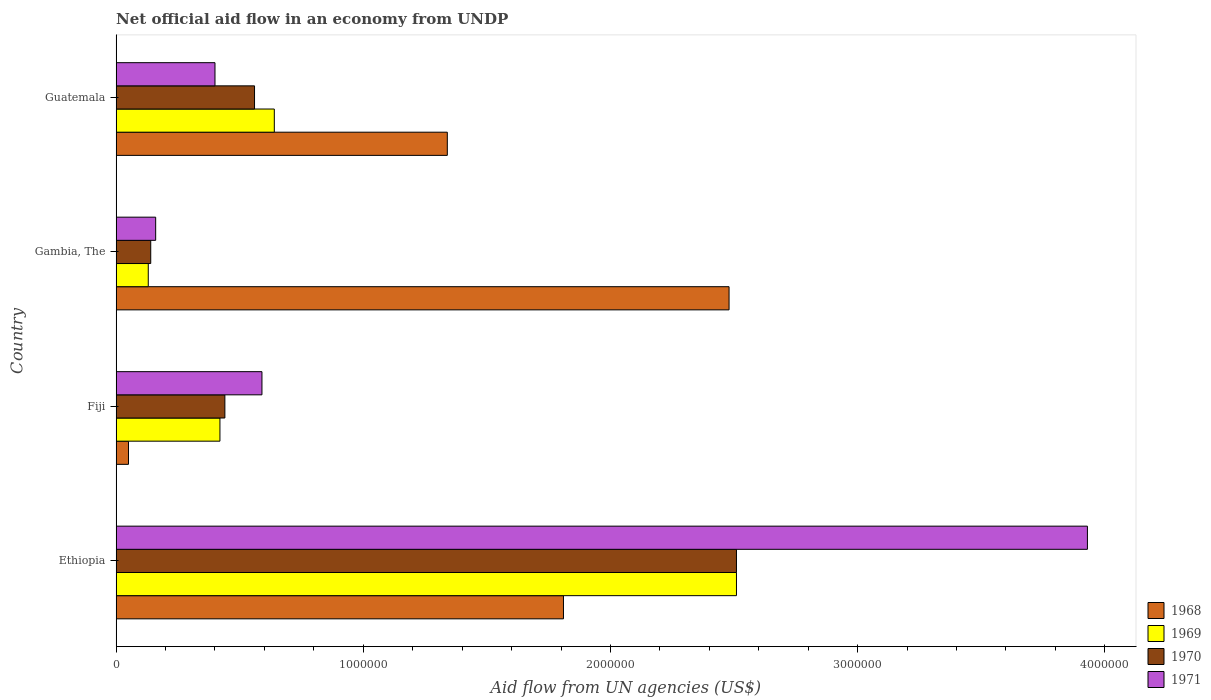Are the number of bars per tick equal to the number of legend labels?
Your answer should be very brief. Yes. Are the number of bars on each tick of the Y-axis equal?
Your answer should be very brief. Yes. What is the label of the 2nd group of bars from the top?
Provide a succinct answer. Gambia, The. What is the net official aid flow in 1968 in Gambia, The?
Keep it short and to the point. 2.48e+06. Across all countries, what is the maximum net official aid flow in 1970?
Make the answer very short. 2.51e+06. Across all countries, what is the minimum net official aid flow in 1968?
Your response must be concise. 5.00e+04. In which country was the net official aid flow in 1968 maximum?
Make the answer very short. Gambia, The. In which country was the net official aid flow in 1968 minimum?
Give a very brief answer. Fiji. What is the total net official aid flow in 1968 in the graph?
Ensure brevity in your answer.  5.68e+06. What is the difference between the net official aid flow in 1968 in Ethiopia and that in Gambia, The?
Your answer should be compact. -6.70e+05. What is the difference between the net official aid flow in 1971 in Guatemala and the net official aid flow in 1968 in Gambia, The?
Your response must be concise. -2.08e+06. What is the average net official aid flow in 1971 per country?
Your response must be concise. 1.27e+06. What is the difference between the net official aid flow in 1968 and net official aid flow in 1971 in Ethiopia?
Ensure brevity in your answer.  -2.12e+06. What is the ratio of the net official aid flow in 1971 in Fiji to that in Guatemala?
Your answer should be very brief. 1.48. Is the net official aid flow in 1971 in Fiji less than that in Guatemala?
Make the answer very short. No. Is the difference between the net official aid flow in 1968 in Fiji and Guatemala greater than the difference between the net official aid flow in 1971 in Fiji and Guatemala?
Provide a succinct answer. No. What is the difference between the highest and the second highest net official aid flow in 1971?
Offer a terse response. 3.34e+06. What is the difference between the highest and the lowest net official aid flow in 1970?
Ensure brevity in your answer.  2.37e+06. Is it the case that in every country, the sum of the net official aid flow in 1971 and net official aid flow in 1969 is greater than the sum of net official aid flow in 1970 and net official aid flow in 1968?
Offer a very short reply. No. What does the 1st bar from the top in Gambia, The represents?
Keep it short and to the point. 1971. What does the 1st bar from the bottom in Ethiopia represents?
Your answer should be compact. 1968. Is it the case that in every country, the sum of the net official aid flow in 1970 and net official aid flow in 1971 is greater than the net official aid flow in 1968?
Ensure brevity in your answer.  No. How many bars are there?
Keep it short and to the point. 16. Are all the bars in the graph horizontal?
Provide a succinct answer. Yes. How many countries are there in the graph?
Ensure brevity in your answer.  4. What is the difference between two consecutive major ticks on the X-axis?
Your answer should be very brief. 1.00e+06. Where does the legend appear in the graph?
Provide a short and direct response. Bottom right. How are the legend labels stacked?
Keep it short and to the point. Vertical. What is the title of the graph?
Provide a succinct answer. Net official aid flow in an economy from UNDP. What is the label or title of the X-axis?
Provide a short and direct response. Aid flow from UN agencies (US$). What is the label or title of the Y-axis?
Ensure brevity in your answer.  Country. What is the Aid flow from UN agencies (US$) in 1968 in Ethiopia?
Your response must be concise. 1.81e+06. What is the Aid flow from UN agencies (US$) in 1969 in Ethiopia?
Keep it short and to the point. 2.51e+06. What is the Aid flow from UN agencies (US$) of 1970 in Ethiopia?
Provide a succinct answer. 2.51e+06. What is the Aid flow from UN agencies (US$) of 1971 in Ethiopia?
Keep it short and to the point. 3.93e+06. What is the Aid flow from UN agencies (US$) of 1969 in Fiji?
Offer a very short reply. 4.20e+05. What is the Aid flow from UN agencies (US$) of 1970 in Fiji?
Your response must be concise. 4.40e+05. What is the Aid flow from UN agencies (US$) in 1971 in Fiji?
Your answer should be compact. 5.90e+05. What is the Aid flow from UN agencies (US$) in 1968 in Gambia, The?
Your response must be concise. 2.48e+06. What is the Aid flow from UN agencies (US$) of 1970 in Gambia, The?
Your response must be concise. 1.40e+05. What is the Aid flow from UN agencies (US$) of 1968 in Guatemala?
Offer a terse response. 1.34e+06. What is the Aid flow from UN agencies (US$) in 1969 in Guatemala?
Make the answer very short. 6.40e+05. What is the Aid flow from UN agencies (US$) in 1970 in Guatemala?
Ensure brevity in your answer.  5.60e+05. What is the Aid flow from UN agencies (US$) of 1971 in Guatemala?
Keep it short and to the point. 4.00e+05. Across all countries, what is the maximum Aid flow from UN agencies (US$) in 1968?
Give a very brief answer. 2.48e+06. Across all countries, what is the maximum Aid flow from UN agencies (US$) of 1969?
Provide a succinct answer. 2.51e+06. Across all countries, what is the maximum Aid flow from UN agencies (US$) in 1970?
Ensure brevity in your answer.  2.51e+06. Across all countries, what is the maximum Aid flow from UN agencies (US$) in 1971?
Ensure brevity in your answer.  3.93e+06. Across all countries, what is the minimum Aid flow from UN agencies (US$) in 1968?
Make the answer very short. 5.00e+04. Across all countries, what is the minimum Aid flow from UN agencies (US$) in 1969?
Offer a terse response. 1.30e+05. Across all countries, what is the minimum Aid flow from UN agencies (US$) in 1970?
Make the answer very short. 1.40e+05. Across all countries, what is the minimum Aid flow from UN agencies (US$) in 1971?
Offer a very short reply. 1.60e+05. What is the total Aid flow from UN agencies (US$) of 1968 in the graph?
Your response must be concise. 5.68e+06. What is the total Aid flow from UN agencies (US$) in 1969 in the graph?
Give a very brief answer. 3.70e+06. What is the total Aid flow from UN agencies (US$) of 1970 in the graph?
Provide a short and direct response. 3.65e+06. What is the total Aid flow from UN agencies (US$) in 1971 in the graph?
Provide a short and direct response. 5.08e+06. What is the difference between the Aid flow from UN agencies (US$) in 1968 in Ethiopia and that in Fiji?
Your answer should be compact. 1.76e+06. What is the difference between the Aid flow from UN agencies (US$) of 1969 in Ethiopia and that in Fiji?
Make the answer very short. 2.09e+06. What is the difference between the Aid flow from UN agencies (US$) in 1970 in Ethiopia and that in Fiji?
Keep it short and to the point. 2.07e+06. What is the difference between the Aid flow from UN agencies (US$) of 1971 in Ethiopia and that in Fiji?
Provide a succinct answer. 3.34e+06. What is the difference between the Aid flow from UN agencies (US$) in 1968 in Ethiopia and that in Gambia, The?
Provide a short and direct response. -6.70e+05. What is the difference between the Aid flow from UN agencies (US$) of 1969 in Ethiopia and that in Gambia, The?
Make the answer very short. 2.38e+06. What is the difference between the Aid flow from UN agencies (US$) of 1970 in Ethiopia and that in Gambia, The?
Your answer should be compact. 2.37e+06. What is the difference between the Aid flow from UN agencies (US$) in 1971 in Ethiopia and that in Gambia, The?
Ensure brevity in your answer.  3.77e+06. What is the difference between the Aid flow from UN agencies (US$) of 1969 in Ethiopia and that in Guatemala?
Give a very brief answer. 1.87e+06. What is the difference between the Aid flow from UN agencies (US$) of 1970 in Ethiopia and that in Guatemala?
Your answer should be very brief. 1.95e+06. What is the difference between the Aid flow from UN agencies (US$) in 1971 in Ethiopia and that in Guatemala?
Give a very brief answer. 3.53e+06. What is the difference between the Aid flow from UN agencies (US$) of 1968 in Fiji and that in Gambia, The?
Ensure brevity in your answer.  -2.43e+06. What is the difference between the Aid flow from UN agencies (US$) in 1971 in Fiji and that in Gambia, The?
Your answer should be very brief. 4.30e+05. What is the difference between the Aid flow from UN agencies (US$) of 1968 in Fiji and that in Guatemala?
Give a very brief answer. -1.29e+06. What is the difference between the Aid flow from UN agencies (US$) in 1968 in Gambia, The and that in Guatemala?
Provide a succinct answer. 1.14e+06. What is the difference between the Aid flow from UN agencies (US$) in 1969 in Gambia, The and that in Guatemala?
Offer a very short reply. -5.10e+05. What is the difference between the Aid flow from UN agencies (US$) of 1970 in Gambia, The and that in Guatemala?
Offer a very short reply. -4.20e+05. What is the difference between the Aid flow from UN agencies (US$) of 1968 in Ethiopia and the Aid flow from UN agencies (US$) of 1969 in Fiji?
Provide a succinct answer. 1.39e+06. What is the difference between the Aid flow from UN agencies (US$) in 1968 in Ethiopia and the Aid flow from UN agencies (US$) in 1970 in Fiji?
Your answer should be very brief. 1.37e+06. What is the difference between the Aid flow from UN agencies (US$) of 1968 in Ethiopia and the Aid flow from UN agencies (US$) of 1971 in Fiji?
Your response must be concise. 1.22e+06. What is the difference between the Aid flow from UN agencies (US$) of 1969 in Ethiopia and the Aid flow from UN agencies (US$) of 1970 in Fiji?
Your answer should be compact. 2.07e+06. What is the difference between the Aid flow from UN agencies (US$) in 1969 in Ethiopia and the Aid flow from UN agencies (US$) in 1971 in Fiji?
Make the answer very short. 1.92e+06. What is the difference between the Aid flow from UN agencies (US$) in 1970 in Ethiopia and the Aid flow from UN agencies (US$) in 1971 in Fiji?
Keep it short and to the point. 1.92e+06. What is the difference between the Aid flow from UN agencies (US$) in 1968 in Ethiopia and the Aid flow from UN agencies (US$) in 1969 in Gambia, The?
Provide a short and direct response. 1.68e+06. What is the difference between the Aid flow from UN agencies (US$) of 1968 in Ethiopia and the Aid flow from UN agencies (US$) of 1970 in Gambia, The?
Give a very brief answer. 1.67e+06. What is the difference between the Aid flow from UN agencies (US$) in 1968 in Ethiopia and the Aid flow from UN agencies (US$) in 1971 in Gambia, The?
Your answer should be compact. 1.65e+06. What is the difference between the Aid flow from UN agencies (US$) in 1969 in Ethiopia and the Aid flow from UN agencies (US$) in 1970 in Gambia, The?
Your answer should be very brief. 2.37e+06. What is the difference between the Aid flow from UN agencies (US$) of 1969 in Ethiopia and the Aid flow from UN agencies (US$) of 1971 in Gambia, The?
Offer a terse response. 2.35e+06. What is the difference between the Aid flow from UN agencies (US$) in 1970 in Ethiopia and the Aid flow from UN agencies (US$) in 1971 in Gambia, The?
Your answer should be very brief. 2.35e+06. What is the difference between the Aid flow from UN agencies (US$) of 1968 in Ethiopia and the Aid flow from UN agencies (US$) of 1969 in Guatemala?
Make the answer very short. 1.17e+06. What is the difference between the Aid flow from UN agencies (US$) in 1968 in Ethiopia and the Aid flow from UN agencies (US$) in 1970 in Guatemala?
Keep it short and to the point. 1.25e+06. What is the difference between the Aid flow from UN agencies (US$) of 1968 in Ethiopia and the Aid flow from UN agencies (US$) of 1971 in Guatemala?
Ensure brevity in your answer.  1.41e+06. What is the difference between the Aid flow from UN agencies (US$) of 1969 in Ethiopia and the Aid flow from UN agencies (US$) of 1970 in Guatemala?
Provide a short and direct response. 1.95e+06. What is the difference between the Aid flow from UN agencies (US$) in 1969 in Ethiopia and the Aid flow from UN agencies (US$) in 1971 in Guatemala?
Offer a very short reply. 2.11e+06. What is the difference between the Aid flow from UN agencies (US$) of 1970 in Ethiopia and the Aid flow from UN agencies (US$) of 1971 in Guatemala?
Ensure brevity in your answer.  2.11e+06. What is the difference between the Aid flow from UN agencies (US$) of 1968 in Fiji and the Aid flow from UN agencies (US$) of 1969 in Gambia, The?
Offer a terse response. -8.00e+04. What is the difference between the Aid flow from UN agencies (US$) of 1969 in Fiji and the Aid flow from UN agencies (US$) of 1971 in Gambia, The?
Your answer should be compact. 2.60e+05. What is the difference between the Aid flow from UN agencies (US$) of 1968 in Fiji and the Aid flow from UN agencies (US$) of 1969 in Guatemala?
Keep it short and to the point. -5.90e+05. What is the difference between the Aid flow from UN agencies (US$) in 1968 in Fiji and the Aid flow from UN agencies (US$) in 1970 in Guatemala?
Make the answer very short. -5.10e+05. What is the difference between the Aid flow from UN agencies (US$) of 1968 in Fiji and the Aid flow from UN agencies (US$) of 1971 in Guatemala?
Offer a very short reply. -3.50e+05. What is the difference between the Aid flow from UN agencies (US$) of 1969 in Fiji and the Aid flow from UN agencies (US$) of 1971 in Guatemala?
Your response must be concise. 2.00e+04. What is the difference between the Aid flow from UN agencies (US$) in 1968 in Gambia, The and the Aid flow from UN agencies (US$) in 1969 in Guatemala?
Ensure brevity in your answer.  1.84e+06. What is the difference between the Aid flow from UN agencies (US$) in 1968 in Gambia, The and the Aid flow from UN agencies (US$) in 1970 in Guatemala?
Your answer should be compact. 1.92e+06. What is the difference between the Aid flow from UN agencies (US$) of 1968 in Gambia, The and the Aid flow from UN agencies (US$) of 1971 in Guatemala?
Offer a very short reply. 2.08e+06. What is the difference between the Aid flow from UN agencies (US$) in 1969 in Gambia, The and the Aid flow from UN agencies (US$) in 1970 in Guatemala?
Provide a succinct answer. -4.30e+05. What is the difference between the Aid flow from UN agencies (US$) of 1969 in Gambia, The and the Aid flow from UN agencies (US$) of 1971 in Guatemala?
Provide a succinct answer. -2.70e+05. What is the difference between the Aid flow from UN agencies (US$) of 1970 in Gambia, The and the Aid flow from UN agencies (US$) of 1971 in Guatemala?
Give a very brief answer. -2.60e+05. What is the average Aid flow from UN agencies (US$) of 1968 per country?
Your answer should be very brief. 1.42e+06. What is the average Aid flow from UN agencies (US$) of 1969 per country?
Offer a very short reply. 9.25e+05. What is the average Aid flow from UN agencies (US$) of 1970 per country?
Offer a very short reply. 9.12e+05. What is the average Aid flow from UN agencies (US$) of 1971 per country?
Provide a short and direct response. 1.27e+06. What is the difference between the Aid flow from UN agencies (US$) of 1968 and Aid flow from UN agencies (US$) of 1969 in Ethiopia?
Your answer should be very brief. -7.00e+05. What is the difference between the Aid flow from UN agencies (US$) of 1968 and Aid flow from UN agencies (US$) of 1970 in Ethiopia?
Provide a succinct answer. -7.00e+05. What is the difference between the Aid flow from UN agencies (US$) of 1968 and Aid flow from UN agencies (US$) of 1971 in Ethiopia?
Keep it short and to the point. -2.12e+06. What is the difference between the Aid flow from UN agencies (US$) of 1969 and Aid flow from UN agencies (US$) of 1970 in Ethiopia?
Ensure brevity in your answer.  0. What is the difference between the Aid flow from UN agencies (US$) in 1969 and Aid flow from UN agencies (US$) in 1971 in Ethiopia?
Provide a short and direct response. -1.42e+06. What is the difference between the Aid flow from UN agencies (US$) in 1970 and Aid flow from UN agencies (US$) in 1971 in Ethiopia?
Offer a terse response. -1.42e+06. What is the difference between the Aid flow from UN agencies (US$) in 1968 and Aid flow from UN agencies (US$) in 1969 in Fiji?
Your answer should be very brief. -3.70e+05. What is the difference between the Aid flow from UN agencies (US$) in 1968 and Aid flow from UN agencies (US$) in 1970 in Fiji?
Your response must be concise. -3.90e+05. What is the difference between the Aid flow from UN agencies (US$) in 1968 and Aid flow from UN agencies (US$) in 1971 in Fiji?
Your answer should be very brief. -5.40e+05. What is the difference between the Aid flow from UN agencies (US$) in 1969 and Aid flow from UN agencies (US$) in 1970 in Fiji?
Keep it short and to the point. -2.00e+04. What is the difference between the Aid flow from UN agencies (US$) in 1969 and Aid flow from UN agencies (US$) in 1971 in Fiji?
Keep it short and to the point. -1.70e+05. What is the difference between the Aid flow from UN agencies (US$) of 1970 and Aid flow from UN agencies (US$) of 1971 in Fiji?
Provide a succinct answer. -1.50e+05. What is the difference between the Aid flow from UN agencies (US$) of 1968 and Aid flow from UN agencies (US$) of 1969 in Gambia, The?
Your answer should be compact. 2.35e+06. What is the difference between the Aid flow from UN agencies (US$) in 1968 and Aid flow from UN agencies (US$) in 1970 in Gambia, The?
Provide a short and direct response. 2.34e+06. What is the difference between the Aid flow from UN agencies (US$) in 1968 and Aid flow from UN agencies (US$) in 1971 in Gambia, The?
Your response must be concise. 2.32e+06. What is the difference between the Aid flow from UN agencies (US$) in 1969 and Aid flow from UN agencies (US$) in 1970 in Gambia, The?
Your answer should be very brief. -10000. What is the difference between the Aid flow from UN agencies (US$) of 1970 and Aid flow from UN agencies (US$) of 1971 in Gambia, The?
Your answer should be compact. -2.00e+04. What is the difference between the Aid flow from UN agencies (US$) of 1968 and Aid flow from UN agencies (US$) of 1970 in Guatemala?
Keep it short and to the point. 7.80e+05. What is the difference between the Aid flow from UN agencies (US$) in 1968 and Aid flow from UN agencies (US$) in 1971 in Guatemala?
Your response must be concise. 9.40e+05. What is the difference between the Aid flow from UN agencies (US$) of 1969 and Aid flow from UN agencies (US$) of 1970 in Guatemala?
Offer a terse response. 8.00e+04. What is the ratio of the Aid flow from UN agencies (US$) in 1968 in Ethiopia to that in Fiji?
Make the answer very short. 36.2. What is the ratio of the Aid flow from UN agencies (US$) in 1969 in Ethiopia to that in Fiji?
Offer a very short reply. 5.98. What is the ratio of the Aid flow from UN agencies (US$) in 1970 in Ethiopia to that in Fiji?
Offer a very short reply. 5.7. What is the ratio of the Aid flow from UN agencies (US$) of 1971 in Ethiopia to that in Fiji?
Your answer should be compact. 6.66. What is the ratio of the Aid flow from UN agencies (US$) in 1968 in Ethiopia to that in Gambia, The?
Provide a succinct answer. 0.73. What is the ratio of the Aid flow from UN agencies (US$) of 1969 in Ethiopia to that in Gambia, The?
Your answer should be very brief. 19.31. What is the ratio of the Aid flow from UN agencies (US$) of 1970 in Ethiopia to that in Gambia, The?
Your response must be concise. 17.93. What is the ratio of the Aid flow from UN agencies (US$) in 1971 in Ethiopia to that in Gambia, The?
Provide a succinct answer. 24.56. What is the ratio of the Aid flow from UN agencies (US$) in 1968 in Ethiopia to that in Guatemala?
Your answer should be very brief. 1.35. What is the ratio of the Aid flow from UN agencies (US$) in 1969 in Ethiopia to that in Guatemala?
Give a very brief answer. 3.92. What is the ratio of the Aid flow from UN agencies (US$) in 1970 in Ethiopia to that in Guatemala?
Offer a terse response. 4.48. What is the ratio of the Aid flow from UN agencies (US$) in 1971 in Ethiopia to that in Guatemala?
Make the answer very short. 9.82. What is the ratio of the Aid flow from UN agencies (US$) in 1968 in Fiji to that in Gambia, The?
Offer a very short reply. 0.02. What is the ratio of the Aid flow from UN agencies (US$) in 1969 in Fiji to that in Gambia, The?
Give a very brief answer. 3.23. What is the ratio of the Aid flow from UN agencies (US$) of 1970 in Fiji to that in Gambia, The?
Give a very brief answer. 3.14. What is the ratio of the Aid flow from UN agencies (US$) of 1971 in Fiji to that in Gambia, The?
Offer a very short reply. 3.69. What is the ratio of the Aid flow from UN agencies (US$) of 1968 in Fiji to that in Guatemala?
Your answer should be very brief. 0.04. What is the ratio of the Aid flow from UN agencies (US$) of 1969 in Fiji to that in Guatemala?
Provide a short and direct response. 0.66. What is the ratio of the Aid flow from UN agencies (US$) in 1970 in Fiji to that in Guatemala?
Keep it short and to the point. 0.79. What is the ratio of the Aid flow from UN agencies (US$) in 1971 in Fiji to that in Guatemala?
Give a very brief answer. 1.48. What is the ratio of the Aid flow from UN agencies (US$) in 1968 in Gambia, The to that in Guatemala?
Ensure brevity in your answer.  1.85. What is the ratio of the Aid flow from UN agencies (US$) of 1969 in Gambia, The to that in Guatemala?
Your response must be concise. 0.2. What is the ratio of the Aid flow from UN agencies (US$) of 1970 in Gambia, The to that in Guatemala?
Provide a short and direct response. 0.25. What is the difference between the highest and the second highest Aid flow from UN agencies (US$) in 1968?
Ensure brevity in your answer.  6.70e+05. What is the difference between the highest and the second highest Aid flow from UN agencies (US$) in 1969?
Keep it short and to the point. 1.87e+06. What is the difference between the highest and the second highest Aid flow from UN agencies (US$) of 1970?
Keep it short and to the point. 1.95e+06. What is the difference between the highest and the second highest Aid flow from UN agencies (US$) of 1971?
Offer a very short reply. 3.34e+06. What is the difference between the highest and the lowest Aid flow from UN agencies (US$) of 1968?
Provide a succinct answer. 2.43e+06. What is the difference between the highest and the lowest Aid flow from UN agencies (US$) in 1969?
Offer a very short reply. 2.38e+06. What is the difference between the highest and the lowest Aid flow from UN agencies (US$) of 1970?
Your response must be concise. 2.37e+06. What is the difference between the highest and the lowest Aid flow from UN agencies (US$) in 1971?
Make the answer very short. 3.77e+06. 